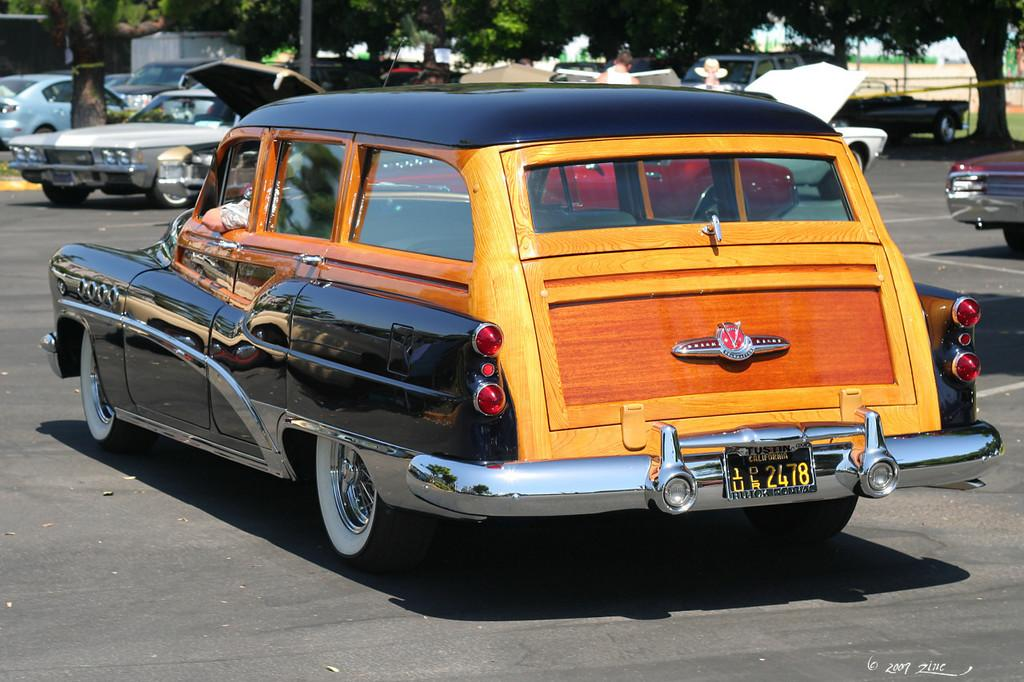What is the main subject of the image? The main subject of the image is a car. Where is the car located in the image? The car is on the road in the image. What colors can be seen on the car? The car has black, yellow, and brown colors. What can be seen in the background of the image? There are parked cars and trees visible in the background of the image. What type of egg is being used to shock the car in the image? There is no egg or shocking activity present in the image; it features a car on the road with parked cars and trees in the background. 